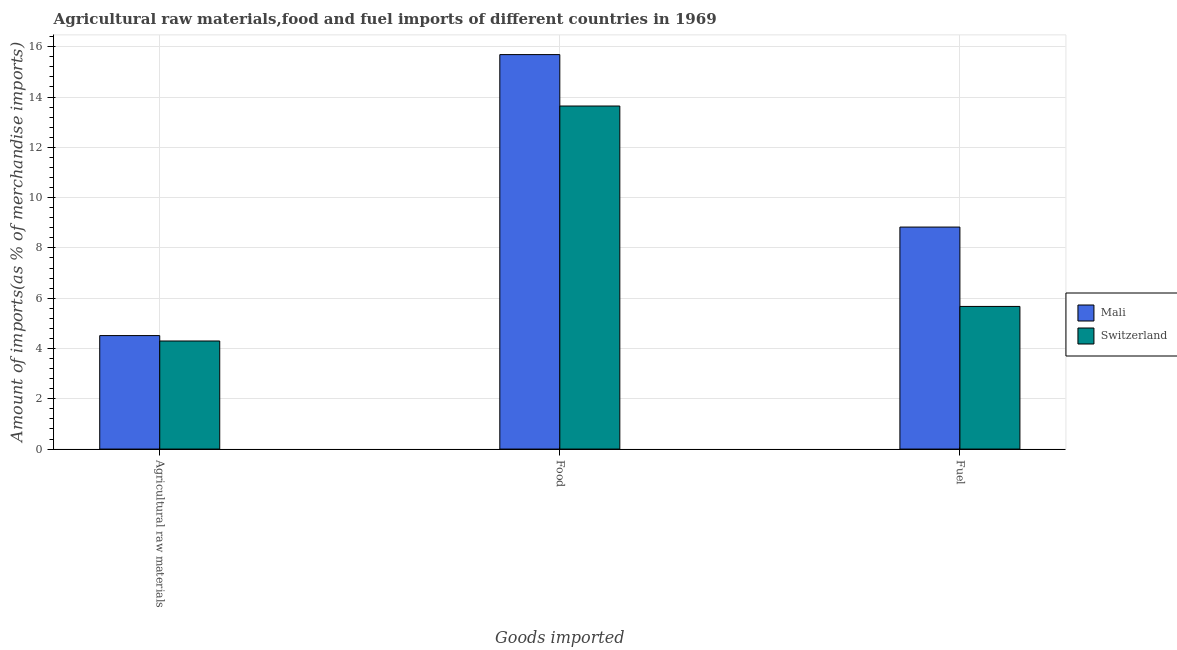How many different coloured bars are there?
Provide a succinct answer. 2. How many bars are there on the 1st tick from the left?
Give a very brief answer. 2. How many bars are there on the 1st tick from the right?
Your response must be concise. 2. What is the label of the 2nd group of bars from the left?
Keep it short and to the point. Food. What is the percentage of food imports in Switzerland?
Offer a very short reply. 13.64. Across all countries, what is the maximum percentage of food imports?
Give a very brief answer. 15.69. Across all countries, what is the minimum percentage of fuel imports?
Make the answer very short. 5.67. In which country was the percentage of food imports maximum?
Provide a short and direct response. Mali. In which country was the percentage of raw materials imports minimum?
Offer a very short reply. Switzerland. What is the total percentage of raw materials imports in the graph?
Keep it short and to the point. 8.81. What is the difference between the percentage of fuel imports in Mali and that in Switzerland?
Your response must be concise. 3.16. What is the difference between the percentage of fuel imports in Switzerland and the percentage of raw materials imports in Mali?
Ensure brevity in your answer.  1.16. What is the average percentage of raw materials imports per country?
Your answer should be very brief. 4.41. What is the difference between the percentage of fuel imports and percentage of raw materials imports in Switzerland?
Your answer should be compact. 1.37. What is the ratio of the percentage of raw materials imports in Mali to that in Switzerland?
Your answer should be very brief. 1.05. Is the percentage of food imports in Mali less than that in Switzerland?
Your response must be concise. No. What is the difference between the highest and the second highest percentage of food imports?
Provide a succinct answer. 2.05. What is the difference between the highest and the lowest percentage of fuel imports?
Ensure brevity in your answer.  3.16. What does the 1st bar from the left in Agricultural raw materials represents?
Give a very brief answer. Mali. What does the 1st bar from the right in Food represents?
Provide a succinct answer. Switzerland. How many bars are there?
Keep it short and to the point. 6. Are all the bars in the graph horizontal?
Your response must be concise. No. How many countries are there in the graph?
Offer a very short reply. 2. What is the difference between two consecutive major ticks on the Y-axis?
Keep it short and to the point. 2. Where does the legend appear in the graph?
Your answer should be very brief. Center right. How many legend labels are there?
Your response must be concise. 2. How are the legend labels stacked?
Provide a short and direct response. Vertical. What is the title of the graph?
Your response must be concise. Agricultural raw materials,food and fuel imports of different countries in 1969. What is the label or title of the X-axis?
Ensure brevity in your answer.  Goods imported. What is the label or title of the Y-axis?
Provide a short and direct response. Amount of imports(as % of merchandise imports). What is the Amount of imports(as % of merchandise imports) of Mali in Agricultural raw materials?
Offer a very short reply. 4.51. What is the Amount of imports(as % of merchandise imports) of Switzerland in Agricultural raw materials?
Offer a very short reply. 4.3. What is the Amount of imports(as % of merchandise imports) of Mali in Food?
Your answer should be very brief. 15.69. What is the Amount of imports(as % of merchandise imports) in Switzerland in Food?
Provide a succinct answer. 13.64. What is the Amount of imports(as % of merchandise imports) in Mali in Fuel?
Your response must be concise. 8.83. What is the Amount of imports(as % of merchandise imports) of Switzerland in Fuel?
Give a very brief answer. 5.67. Across all Goods imported, what is the maximum Amount of imports(as % of merchandise imports) of Mali?
Your answer should be compact. 15.69. Across all Goods imported, what is the maximum Amount of imports(as % of merchandise imports) of Switzerland?
Offer a very short reply. 13.64. Across all Goods imported, what is the minimum Amount of imports(as % of merchandise imports) in Mali?
Your answer should be very brief. 4.51. Across all Goods imported, what is the minimum Amount of imports(as % of merchandise imports) of Switzerland?
Offer a very short reply. 4.3. What is the total Amount of imports(as % of merchandise imports) in Mali in the graph?
Your answer should be very brief. 29.03. What is the total Amount of imports(as % of merchandise imports) of Switzerland in the graph?
Offer a terse response. 23.61. What is the difference between the Amount of imports(as % of merchandise imports) of Mali in Agricultural raw materials and that in Food?
Your answer should be very brief. -11.17. What is the difference between the Amount of imports(as % of merchandise imports) of Switzerland in Agricultural raw materials and that in Food?
Make the answer very short. -9.34. What is the difference between the Amount of imports(as % of merchandise imports) in Mali in Agricultural raw materials and that in Fuel?
Your response must be concise. -4.32. What is the difference between the Amount of imports(as % of merchandise imports) of Switzerland in Agricultural raw materials and that in Fuel?
Offer a terse response. -1.37. What is the difference between the Amount of imports(as % of merchandise imports) in Mali in Food and that in Fuel?
Offer a terse response. 6.86. What is the difference between the Amount of imports(as % of merchandise imports) of Switzerland in Food and that in Fuel?
Give a very brief answer. 7.97. What is the difference between the Amount of imports(as % of merchandise imports) of Mali in Agricultural raw materials and the Amount of imports(as % of merchandise imports) of Switzerland in Food?
Your answer should be very brief. -9.13. What is the difference between the Amount of imports(as % of merchandise imports) in Mali in Agricultural raw materials and the Amount of imports(as % of merchandise imports) in Switzerland in Fuel?
Provide a short and direct response. -1.16. What is the difference between the Amount of imports(as % of merchandise imports) of Mali in Food and the Amount of imports(as % of merchandise imports) of Switzerland in Fuel?
Your answer should be compact. 10.01. What is the average Amount of imports(as % of merchandise imports) of Mali per Goods imported?
Ensure brevity in your answer.  9.68. What is the average Amount of imports(as % of merchandise imports) of Switzerland per Goods imported?
Ensure brevity in your answer.  7.87. What is the difference between the Amount of imports(as % of merchandise imports) in Mali and Amount of imports(as % of merchandise imports) in Switzerland in Agricultural raw materials?
Offer a very short reply. 0.22. What is the difference between the Amount of imports(as % of merchandise imports) in Mali and Amount of imports(as % of merchandise imports) in Switzerland in Food?
Provide a succinct answer. 2.05. What is the difference between the Amount of imports(as % of merchandise imports) of Mali and Amount of imports(as % of merchandise imports) of Switzerland in Fuel?
Your response must be concise. 3.16. What is the ratio of the Amount of imports(as % of merchandise imports) of Mali in Agricultural raw materials to that in Food?
Offer a terse response. 0.29. What is the ratio of the Amount of imports(as % of merchandise imports) of Switzerland in Agricultural raw materials to that in Food?
Your answer should be compact. 0.32. What is the ratio of the Amount of imports(as % of merchandise imports) in Mali in Agricultural raw materials to that in Fuel?
Provide a succinct answer. 0.51. What is the ratio of the Amount of imports(as % of merchandise imports) in Switzerland in Agricultural raw materials to that in Fuel?
Your answer should be compact. 0.76. What is the ratio of the Amount of imports(as % of merchandise imports) in Mali in Food to that in Fuel?
Give a very brief answer. 1.78. What is the ratio of the Amount of imports(as % of merchandise imports) in Switzerland in Food to that in Fuel?
Offer a very short reply. 2.4. What is the difference between the highest and the second highest Amount of imports(as % of merchandise imports) of Mali?
Keep it short and to the point. 6.86. What is the difference between the highest and the second highest Amount of imports(as % of merchandise imports) in Switzerland?
Offer a very short reply. 7.97. What is the difference between the highest and the lowest Amount of imports(as % of merchandise imports) in Mali?
Provide a short and direct response. 11.17. What is the difference between the highest and the lowest Amount of imports(as % of merchandise imports) in Switzerland?
Provide a short and direct response. 9.34. 